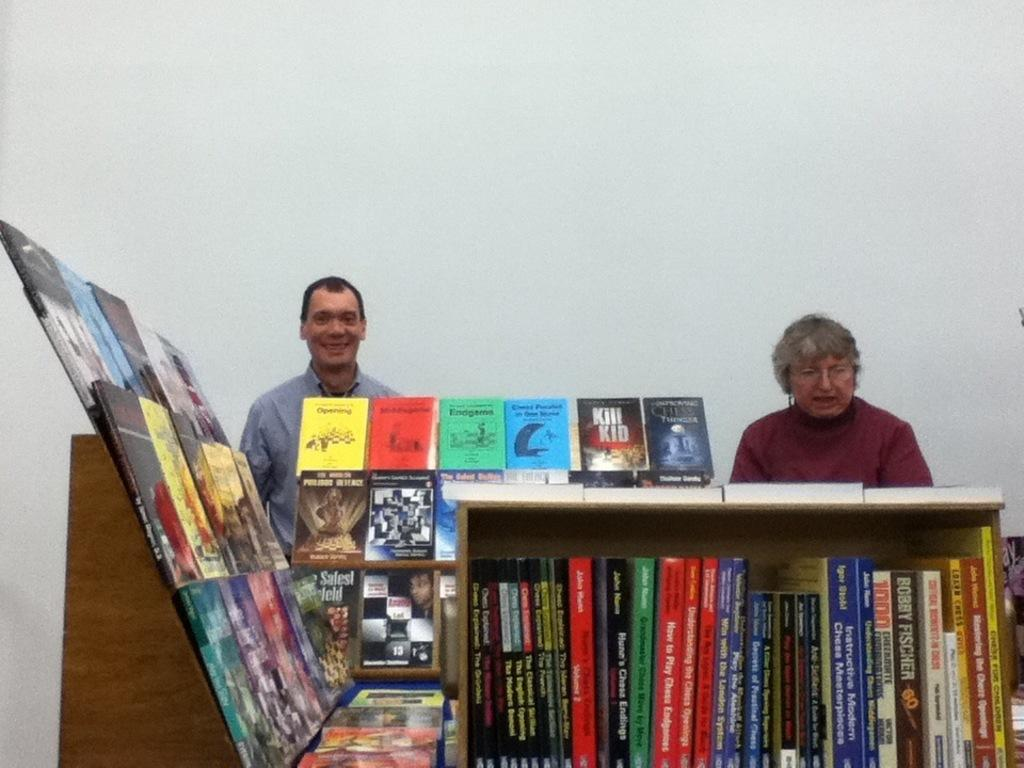<image>
Summarize the visual content of the image. a book called how to play chess is sitting in a bookcase 